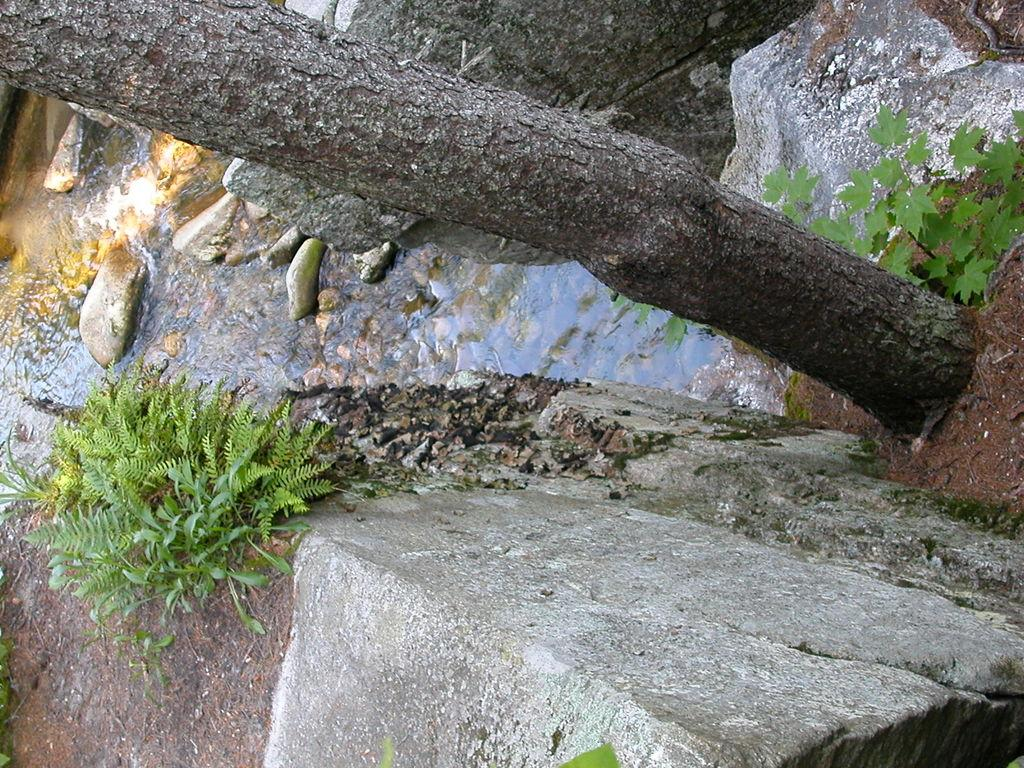What type of natural elements can be seen in the image? There are plants, rocks, and a tree trunk visible in the image. What man-made structure is present in the image? There is a fence in the image. Is there any water visible in the image? Yes, there is water visible in the image. Can you describe the lighting conditions in the image? The image was likely taken during the day, as there is sufficient light to see the details. What type of cheese is hanging from the tree trunk in the image? There is no cheese present in the image; it features plants, rocks, a fence, water, and a tree trunk. What type of frame surrounds the image? The image does not have a frame; the question refers to the physical presentation of the image, not the content within it. 